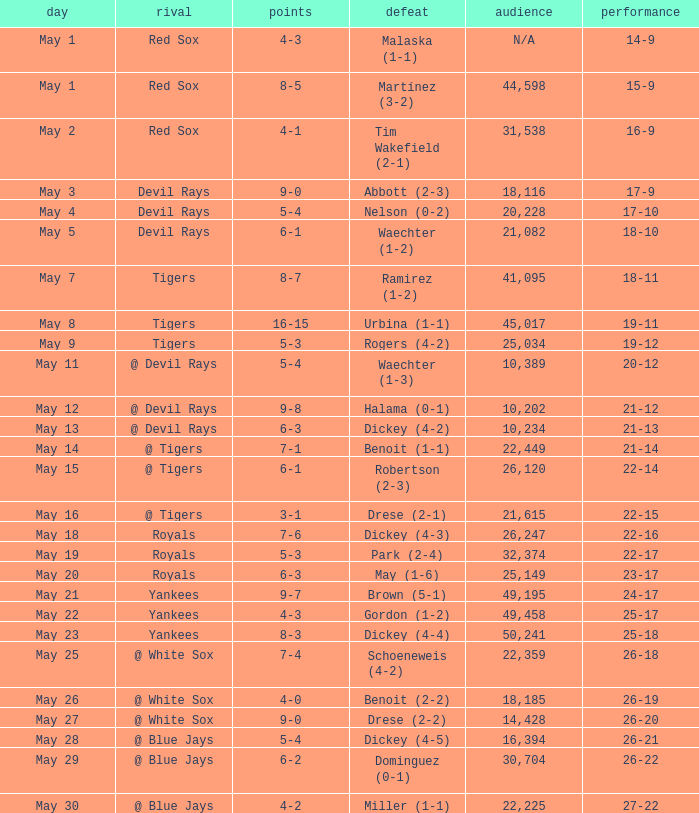What was the tally of the game in which drese (2-2) experienced a loss? 9-0. 